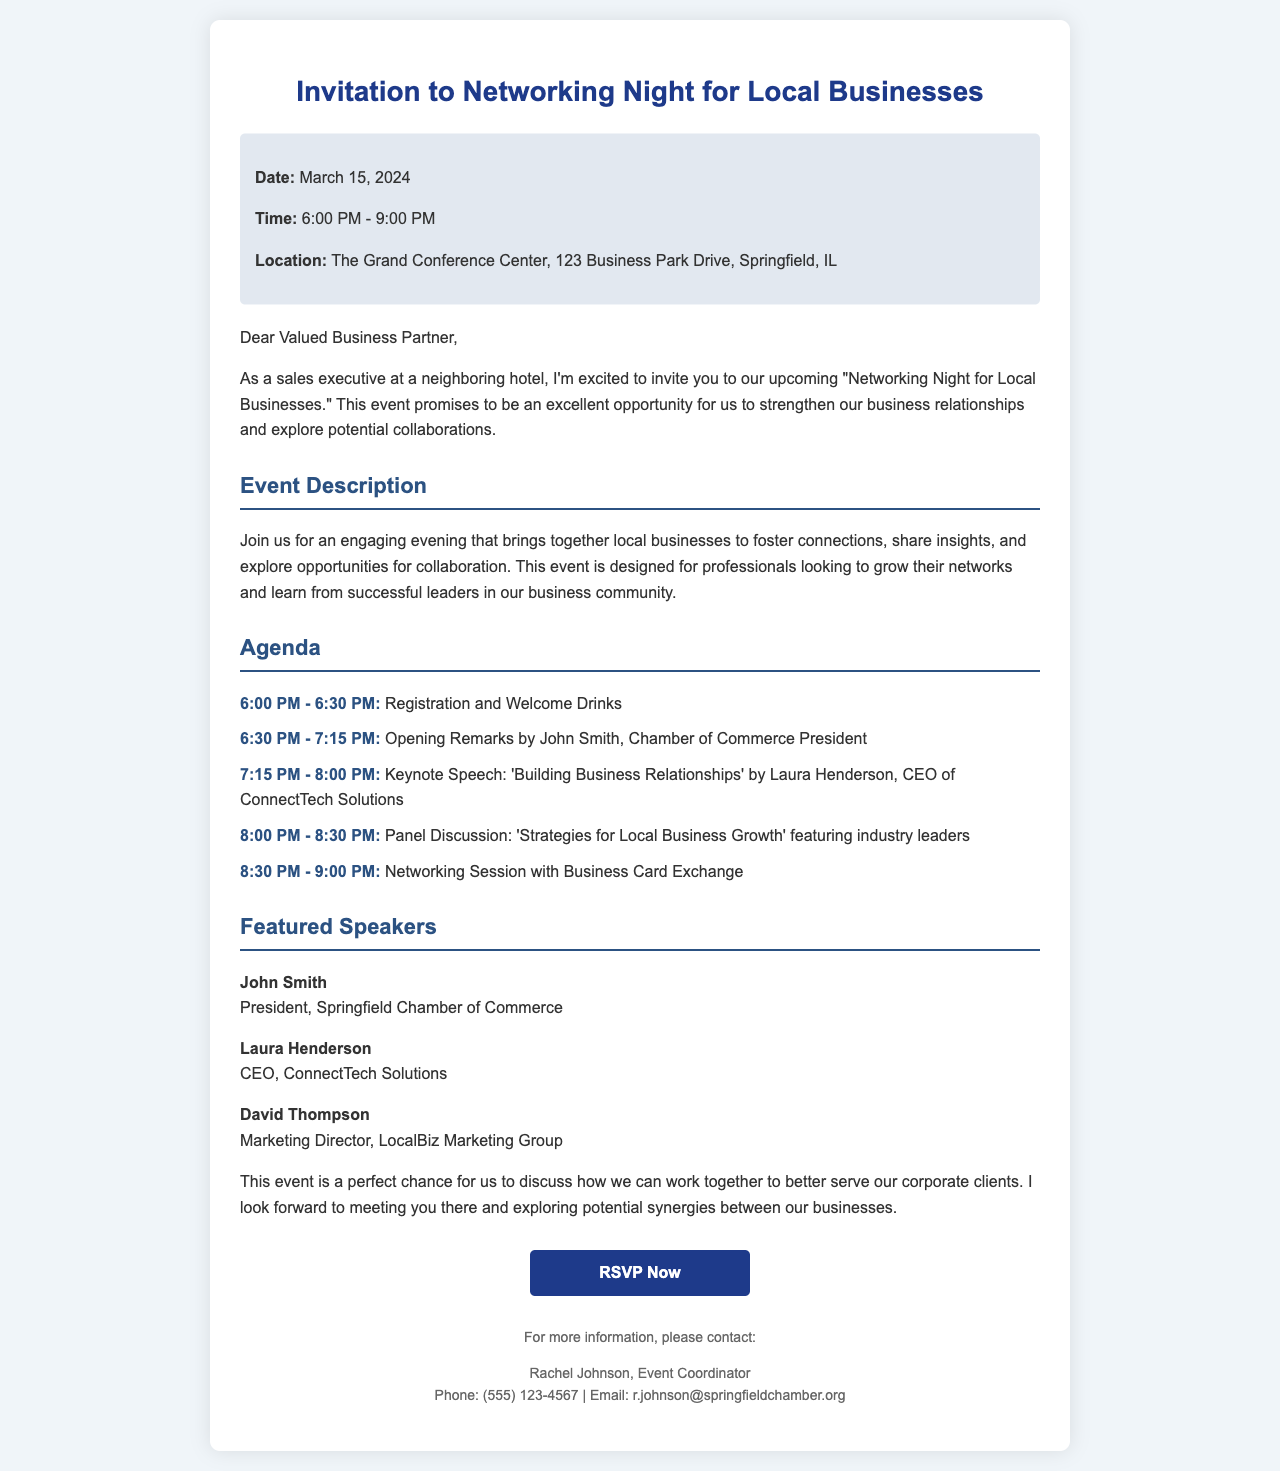What is the date of the event? The date of the event is specified in the document, which states that it will take place on March 15, 2024.
Answer: March 15, 2024 What time does the networking event start? The document mentions that the networking event starts at 6:00 PM.
Answer: 6:00 PM Who is the keynote speaker? The keynote speaker is mentioned in the agenda of the event, specifically as Laura Henderson, CEO of ConnectTech Solutions.
Answer: Laura Henderson What is the location of the event? The document provides the location, which is The Grand Conference Center, 123 Business Park Drive, Springfield, IL.
Answer: The Grand Conference Center, 123 Business Park Drive, Springfield, IL How long is the networking session? The networking session is outlined in the agenda with the time frame from 8:30 PM to 9:00 PM, which is 30 minutes.
Answer: 30 minutes Which speaker is from the Springfield Chamber of Commerce? The document identifies John Smith as the President of the Springfield Chamber of Commerce.
Answer: John Smith What is the main topic of the keynote speech? The document lists the topic of the keynote speech as 'Building Business Relationships.'
Answer: Building Business Relationships What is the purpose of the networking night? The document states that the main purpose is to strengthen business relationships and explore potential collaborations.
Answer: Strengthen business relationships and explore potential collaborations 